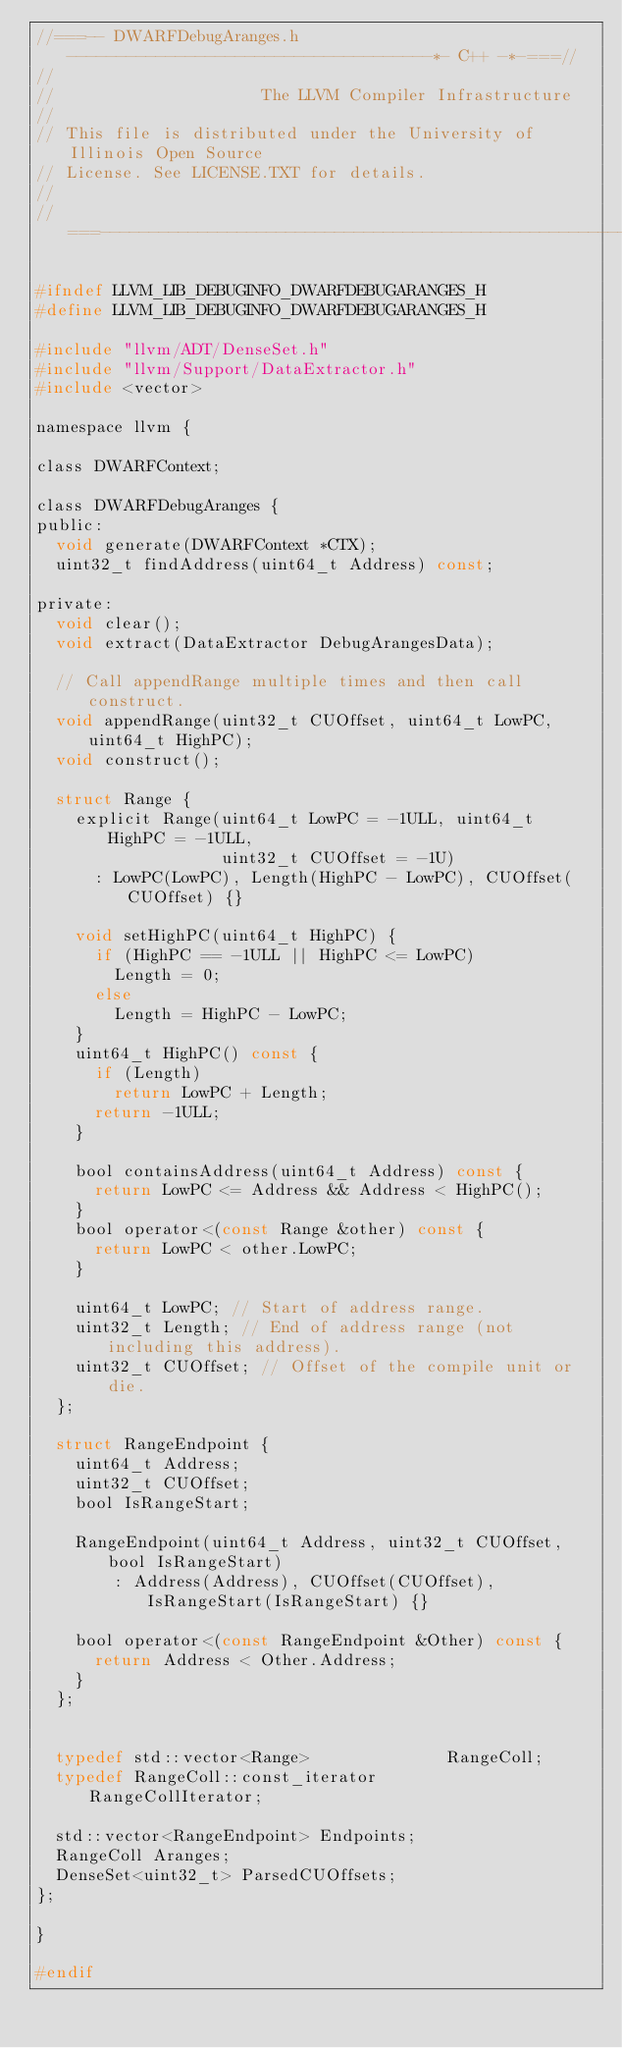Convert code to text. <code><loc_0><loc_0><loc_500><loc_500><_C_>//===-- DWARFDebugAranges.h -------------------------------------*- C++ -*-===//
//
//                     The LLVM Compiler Infrastructure
//
// This file is distributed under the University of Illinois Open Source
// License. See LICENSE.TXT for details.
//
//===----------------------------------------------------------------------===//

#ifndef LLVM_LIB_DEBUGINFO_DWARFDEBUGARANGES_H
#define LLVM_LIB_DEBUGINFO_DWARFDEBUGARANGES_H

#include "llvm/ADT/DenseSet.h"
#include "llvm/Support/DataExtractor.h"
#include <vector>

namespace llvm {

class DWARFContext;

class DWARFDebugAranges {
public:
  void generate(DWARFContext *CTX);
  uint32_t findAddress(uint64_t Address) const;

private:
  void clear();
  void extract(DataExtractor DebugArangesData);

  // Call appendRange multiple times and then call construct.
  void appendRange(uint32_t CUOffset, uint64_t LowPC, uint64_t HighPC);
  void construct();

  struct Range {
    explicit Range(uint64_t LowPC = -1ULL, uint64_t HighPC = -1ULL,
                   uint32_t CUOffset = -1U)
      : LowPC(LowPC), Length(HighPC - LowPC), CUOffset(CUOffset) {}

    void setHighPC(uint64_t HighPC) {
      if (HighPC == -1ULL || HighPC <= LowPC)
        Length = 0;
      else
        Length = HighPC - LowPC;
    }
    uint64_t HighPC() const {
      if (Length)
        return LowPC + Length;
      return -1ULL;
    }

    bool containsAddress(uint64_t Address) const {
      return LowPC <= Address && Address < HighPC();
    }
    bool operator<(const Range &other) const {
      return LowPC < other.LowPC;
    }

    uint64_t LowPC; // Start of address range.
    uint32_t Length; // End of address range (not including this address).
    uint32_t CUOffset; // Offset of the compile unit or die.
  };

  struct RangeEndpoint {
    uint64_t Address;
    uint32_t CUOffset;
    bool IsRangeStart;

    RangeEndpoint(uint64_t Address, uint32_t CUOffset, bool IsRangeStart)
        : Address(Address), CUOffset(CUOffset), IsRangeStart(IsRangeStart) {}

    bool operator<(const RangeEndpoint &Other) const {
      return Address < Other.Address;
    }
  };


  typedef std::vector<Range>              RangeColl;
  typedef RangeColl::const_iterator       RangeCollIterator;

  std::vector<RangeEndpoint> Endpoints;
  RangeColl Aranges;
  DenseSet<uint32_t> ParsedCUOffsets;
};

}

#endif
</code> 